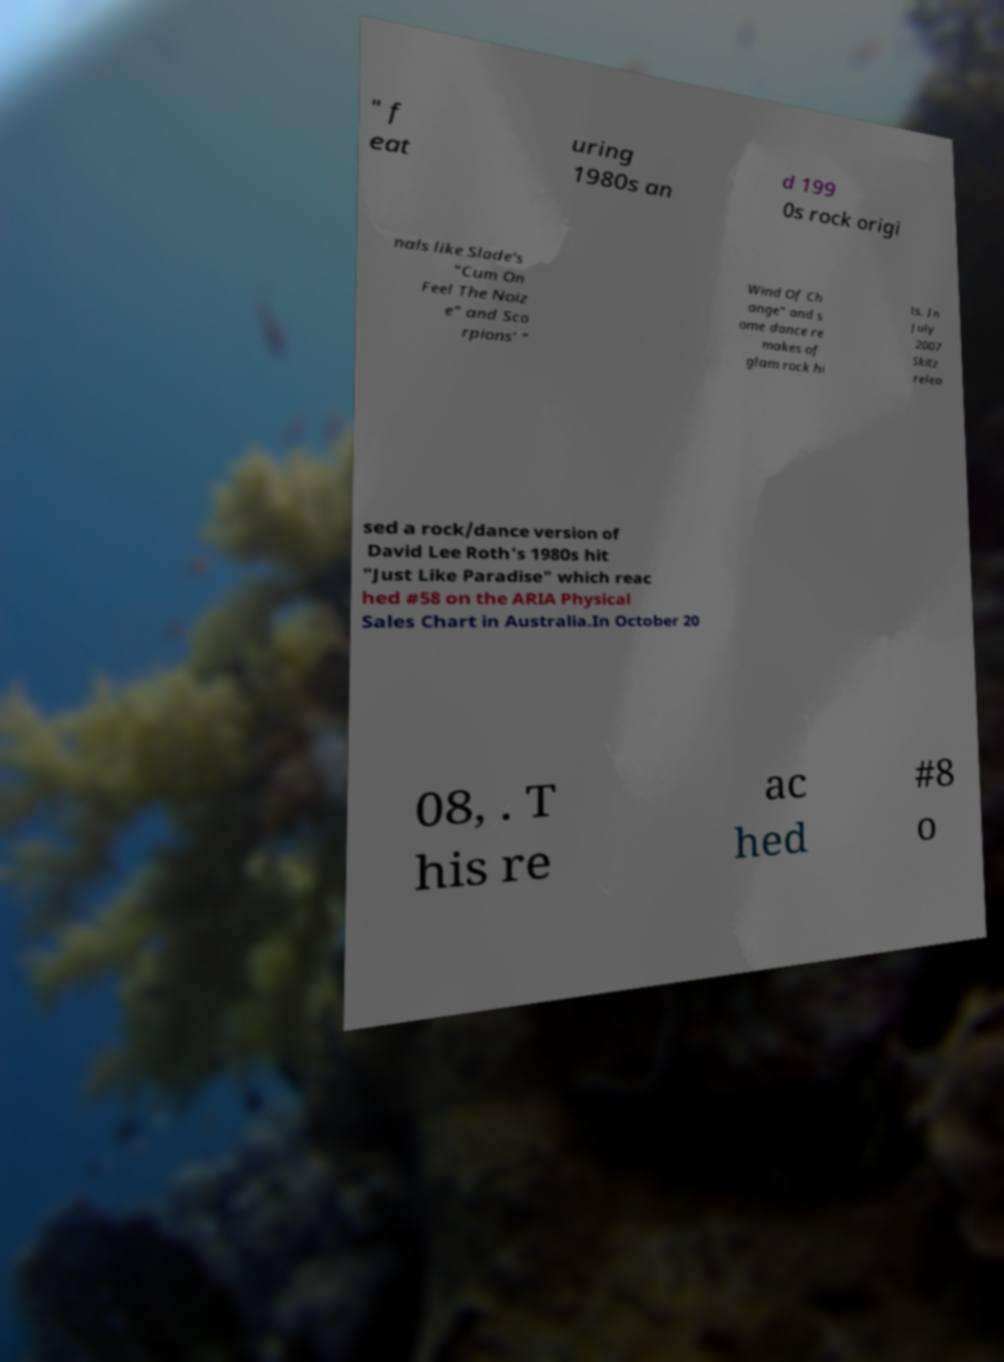Could you extract and type out the text from this image? " f eat uring 1980s an d 199 0s rock origi nals like Slade's "Cum On Feel The Noiz e" and Sco rpions' " Wind Of Ch ange" and s ome dance re makes of glam rock hi ts. In July 2007 Skitz relea sed a rock/dance version of David Lee Roth's 1980s hit "Just Like Paradise" which reac hed #58 on the ARIA Physical Sales Chart in Australia.In October 20 08, . T his re ac hed #8 o 